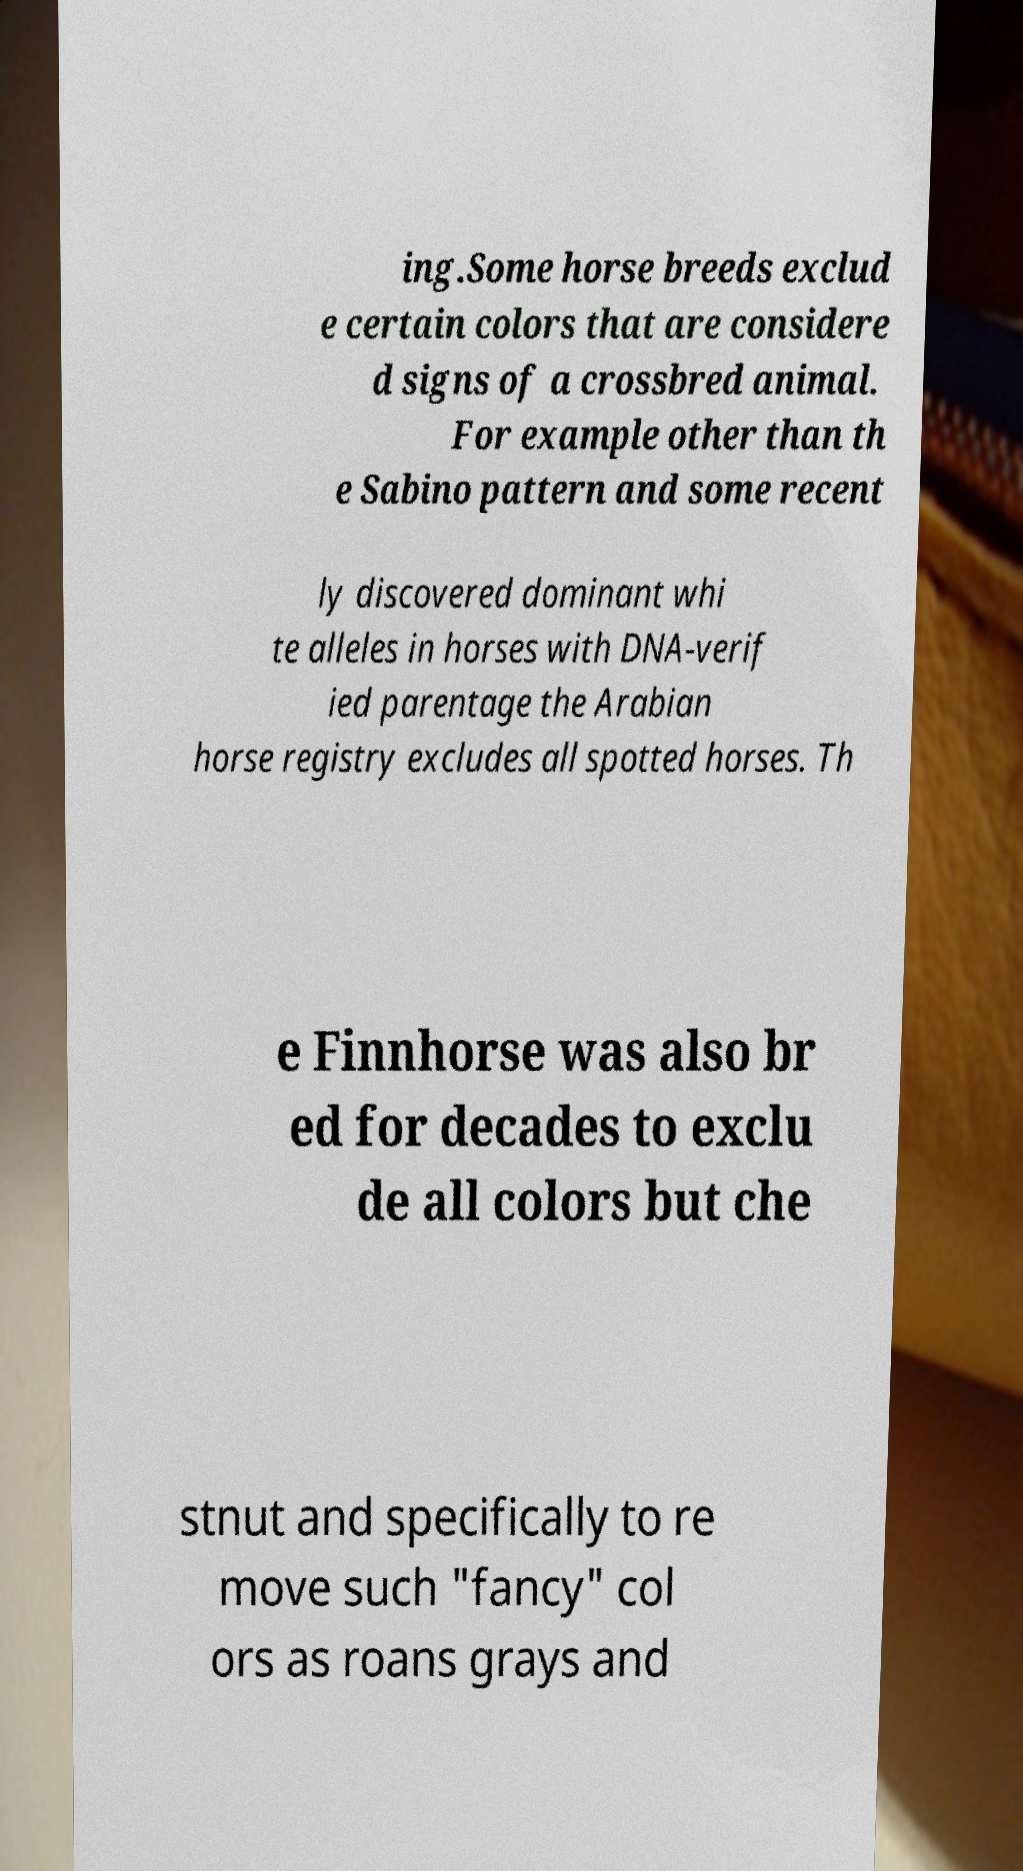I need the written content from this picture converted into text. Can you do that? ing.Some horse breeds exclud e certain colors that are considere d signs of a crossbred animal. For example other than th e Sabino pattern and some recent ly discovered dominant whi te alleles in horses with DNA-verif ied parentage the Arabian horse registry excludes all spotted horses. Th e Finnhorse was also br ed for decades to exclu de all colors but che stnut and specifically to re move such "fancy" col ors as roans grays and 